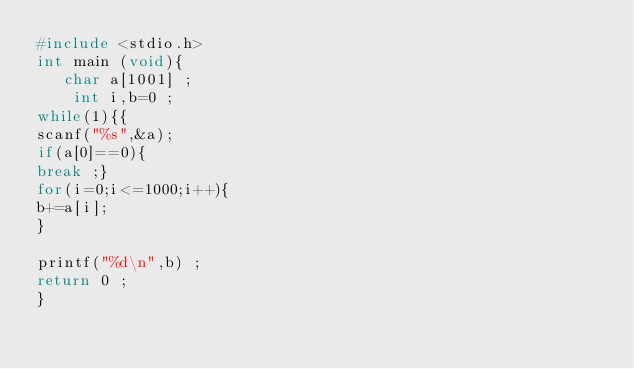Convert code to text. <code><loc_0><loc_0><loc_500><loc_500><_C_>#include <stdio.h>
int main (void){
   char a[1001] ;
    int i,b=0 ;
while(1){{
scanf("%s",&a);
if(a[0]==0){
break ;}
for(i=0;i<=1000;i++){
b+=a[i];
}

printf("%d\n",b) ;
return 0 ;
}</code> 